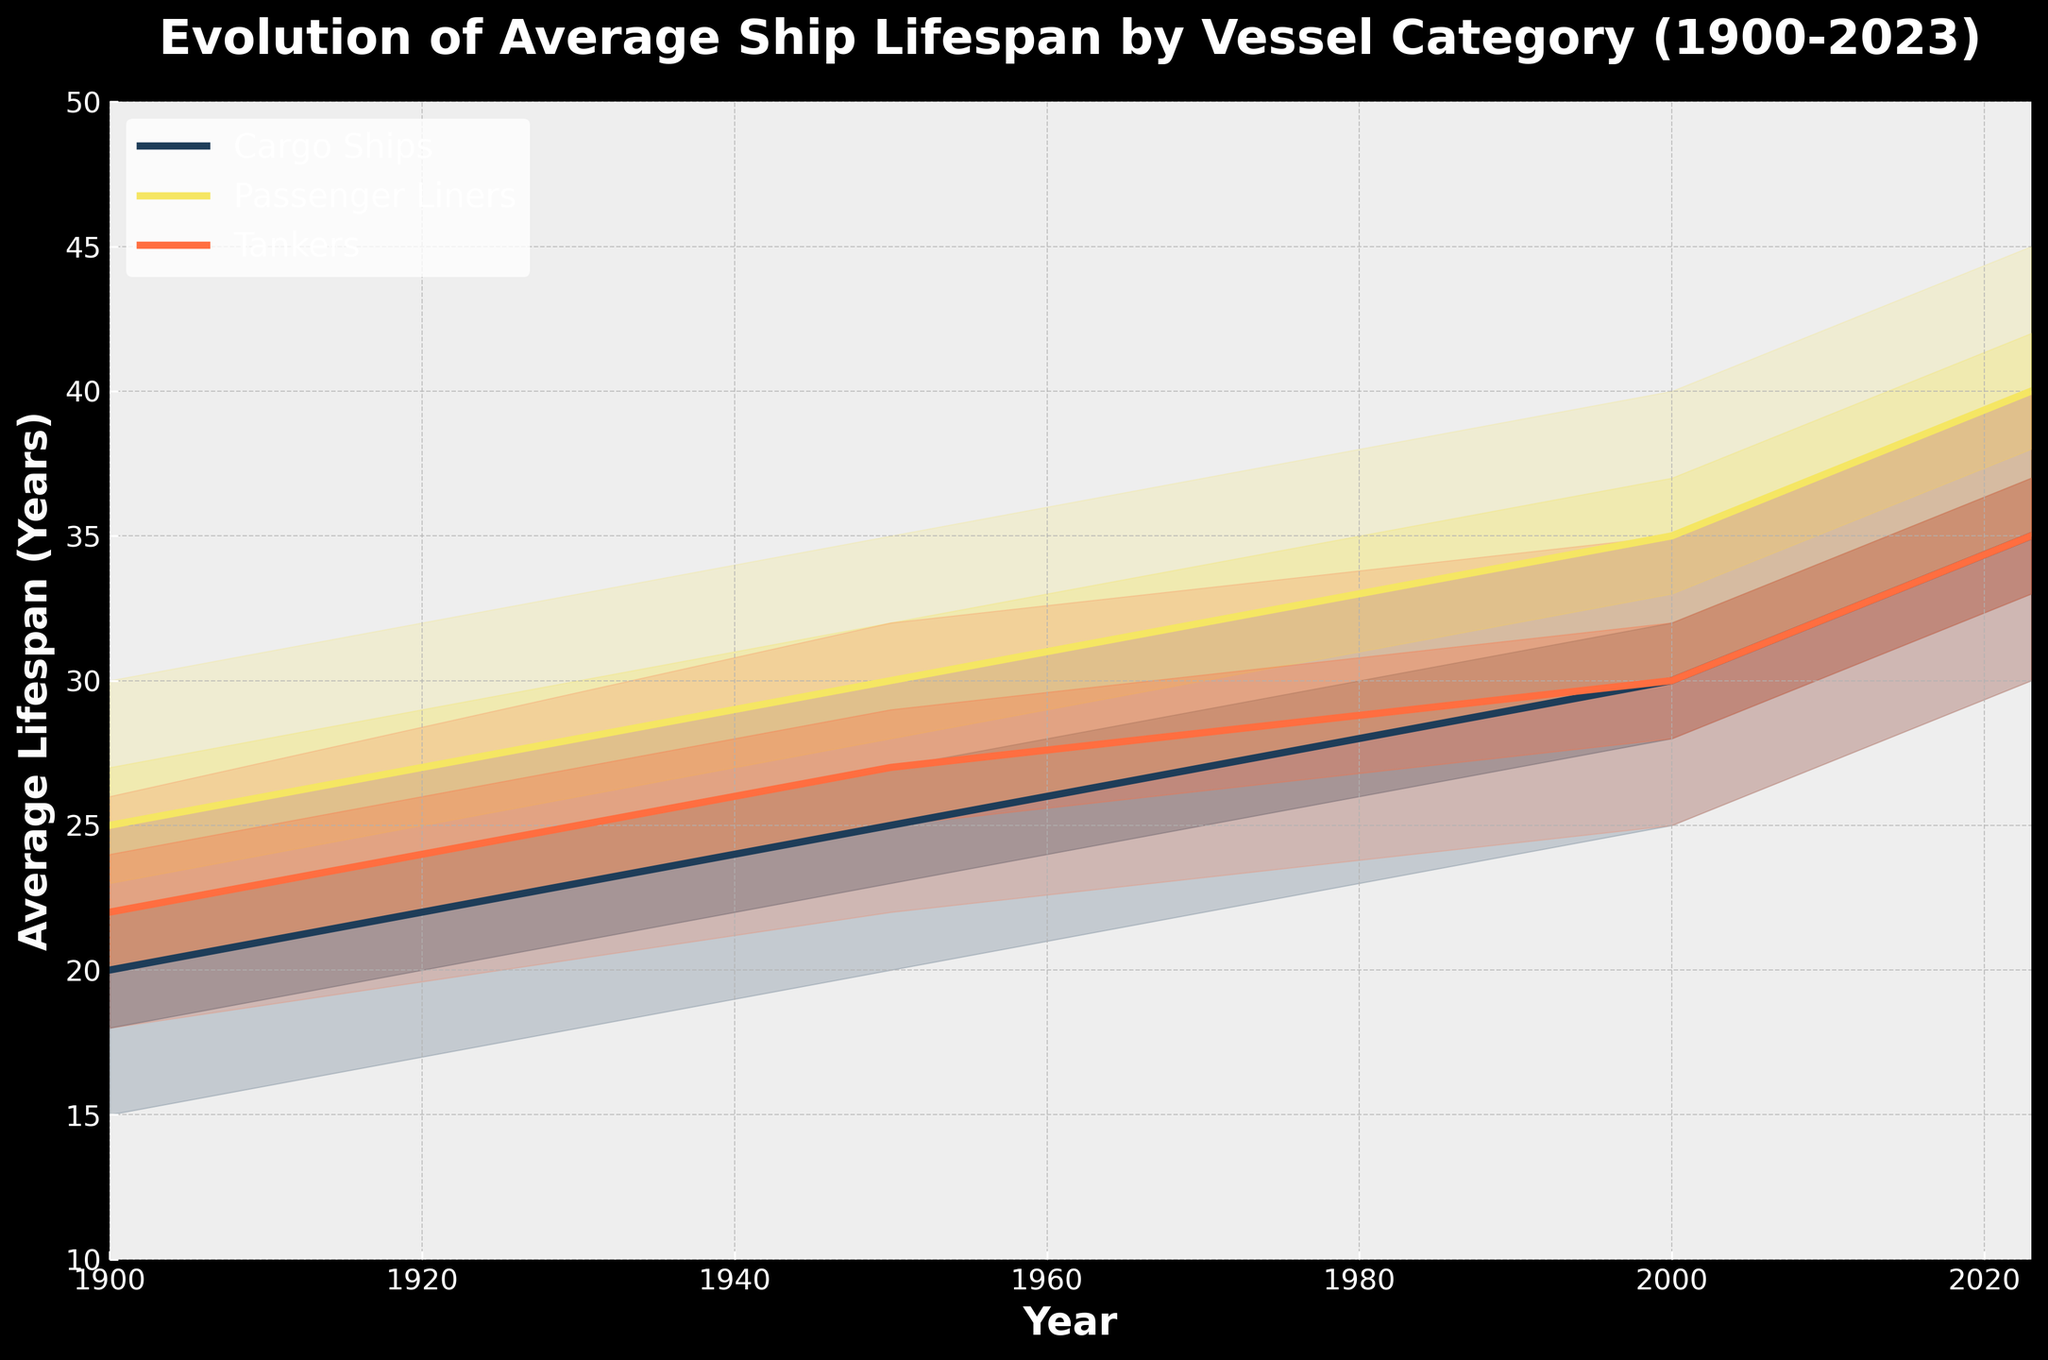What is the title of the figure? The title is displayed prominently at the top of the figure.
Answer: Evolution of Average Ship Lifespan by Vessel Category (1900-2023) Which vessel type had the highest average lifespan in 2023? By observing the data points at the year 2023, we see that Passenger Liners had the highest average lifespan.
Answer: Passenger Liners What is the range of average lifespans for Tankers in 2000? The range is represented by the lowest and highest values for Tankers in 2000. The values range from 25 to 35 years.
Answer: 25 to 35 years How did the average lifespan of Cargo Ships change from 1950 to 2000? The average lifespan of Cargo Ships increased from 25 years in 1950 to 30 years in 2000.
Answer: Increased by 5 years Compare the median average lifespan of Passenger Liners and Cargo Ships in the year 1950. The median average lifespan can be found from the middle value of the range. For Passenger Liners in 1950, it is 30 years, and for Cargo Ships, it is 25 years.
Answer: Passenger Liners have 5 years more median lifespan than Cargo Ships in 1950 What is the overall trend in average lifespan for all vessel types from 1900 to 2023? Observing all vessel types from 1900 to 2023, there is a clear upward trend in the average lifespan.
Answer: Upward trend By how many years did the median lifespan of Tankers increase from 1900 to 1950? The median lifespan of Tankers in 1900 was 22 years, and in 1950 it was 27 years, leading to an increase of 5 years.
Answer: 5 years What can you infer from comparing the low-mid values of Passenger Liners in 1900 and 2000? The low-mid value for Passenger Liners in 1900 is 23 years, and it is 33 years in 2000, indicating an increase over time.
Answer: Increased by 10 years Which vessel type shows the most significant increase in lifespan between 1900 and 2023? By comparing changes in average lifespans from 1900 to 2023 across all vessel types, Passenger Liners show the most significant increase from 25 to 40 years.
Answer: Passenger Liners What is the maximum average lifespan recorded in the chart? The highest value represented in the chart is for Passenger Liners in 2023, which is 45 years.
Answer: 45 years 